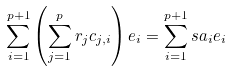<formula> <loc_0><loc_0><loc_500><loc_500>\sum _ { i = 1 } ^ { p + 1 } \left ( \sum _ { j = 1 } ^ { p } r _ { j } c _ { j , i } \right ) e _ { i } = \sum _ { i = 1 } ^ { p + 1 } s a _ { i } e _ { i }</formula> 